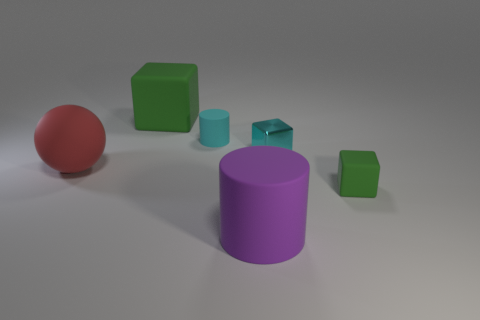There is a big purple object; are there any large red things to the right of it?
Offer a terse response. No. There is a green matte thing that is on the left side of the tiny cyan matte object; are there any tiny cyan shiny cubes behind it?
Provide a succinct answer. No. Are there the same number of large rubber spheres behind the purple rubber cylinder and big green blocks to the right of the small matte block?
Your answer should be very brief. No. The tiny block that is the same material as the red object is what color?
Ensure brevity in your answer.  Green. Are there any other tiny red spheres made of the same material as the red sphere?
Make the answer very short. No. How many things are either rubber balls or cyan blocks?
Your answer should be very brief. 2. Is the material of the large purple cylinder the same as the green block that is in front of the ball?
Provide a succinct answer. Yes. There is a green object that is behind the small matte cube; what size is it?
Offer a terse response. Large. Are there fewer cyan matte blocks than cubes?
Keep it short and to the point. Yes. Are there any spheres of the same color as the big matte cylinder?
Your answer should be compact. No. 